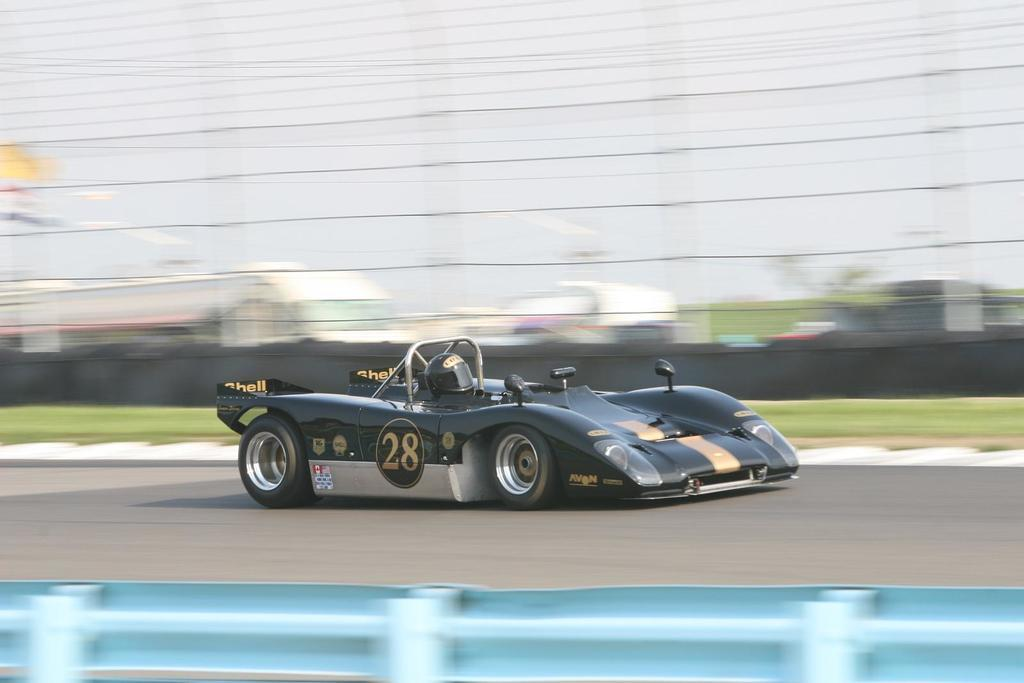What is the person in the image doing? There is a person riding a car in the image. Where is the car located? The car is on the road. What can be seen in the background of the image? There are sheds, fences, trees, and wires in the background of the image. What type of tin can be seen in the image? There is no tin present in the image. What is the level of thrill experienced by the person riding the car in the image? The level of thrill experienced by the person riding the car cannot be determined from the image alone. 